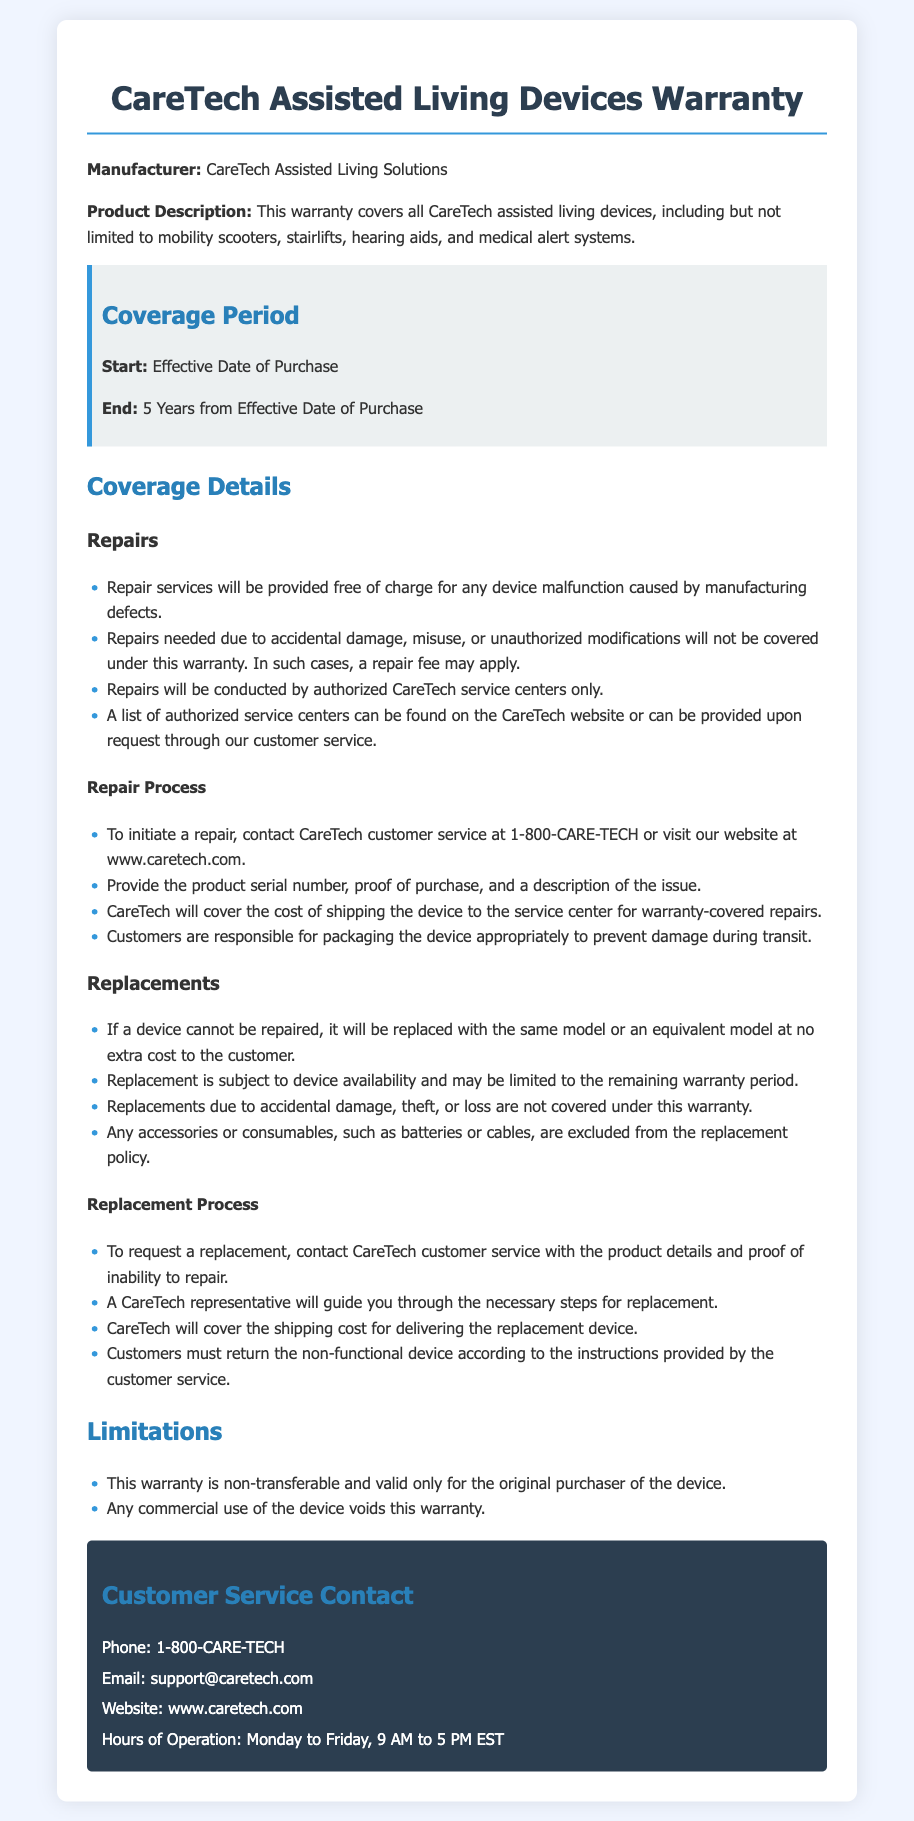What is the warranty coverage period? The warranty coverage period starts on the effective date of purchase and ends 5 years from that date.
Answer: 5 years Who is the manufacturer of the devices? The manufacturer of the devices is specified in the document.
Answer: CareTech Assisted Living Solutions What must be provided to initiate a repair? The document lists the required information to initiate a repair process.
Answer: Product serial number, proof of purchase, and description of the issue Are replacements for accidental damage covered under this warranty? The document specifies what types of replacements are covered.
Answer: No What happens if a device cannot be repaired? The warranty document outlines the procedure if a device is beyond repair.
Answer: It will be replaced with the same or equivalent model at no cost What is the contact phone number for customer service? The customer service contact information is detailed in the document.
Answer: 1-800-CARE-TECH Is this warranty transferable? The warranty's transferability is addressed in the limitations section of the document.
Answer: No During what hours is customer service available? Customer service hours of operation are mentioned in the contact info section.
Answer: Monday to Friday, 9 AM to 5 PM EST 